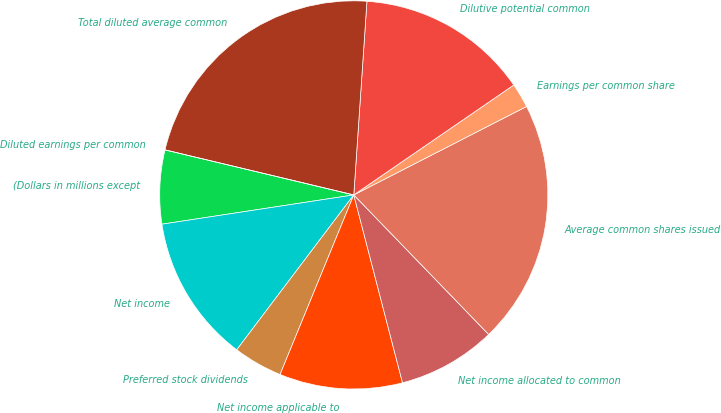Convert chart to OTSL. <chart><loc_0><loc_0><loc_500><loc_500><pie_chart><fcel>(Dollars in millions except<fcel>Net income<fcel>Preferred stock dividends<fcel>Net income applicable to<fcel>Net income allocated to common<fcel>Average common shares issued<fcel>Earnings per common share<fcel>Dilutive potential common<fcel>Total diluted average common<fcel>Diluted earnings per common<nl><fcel>6.14%<fcel>12.29%<fcel>4.1%<fcel>10.24%<fcel>8.19%<fcel>20.3%<fcel>2.05%<fcel>14.34%<fcel>22.35%<fcel>0.0%<nl></chart> 